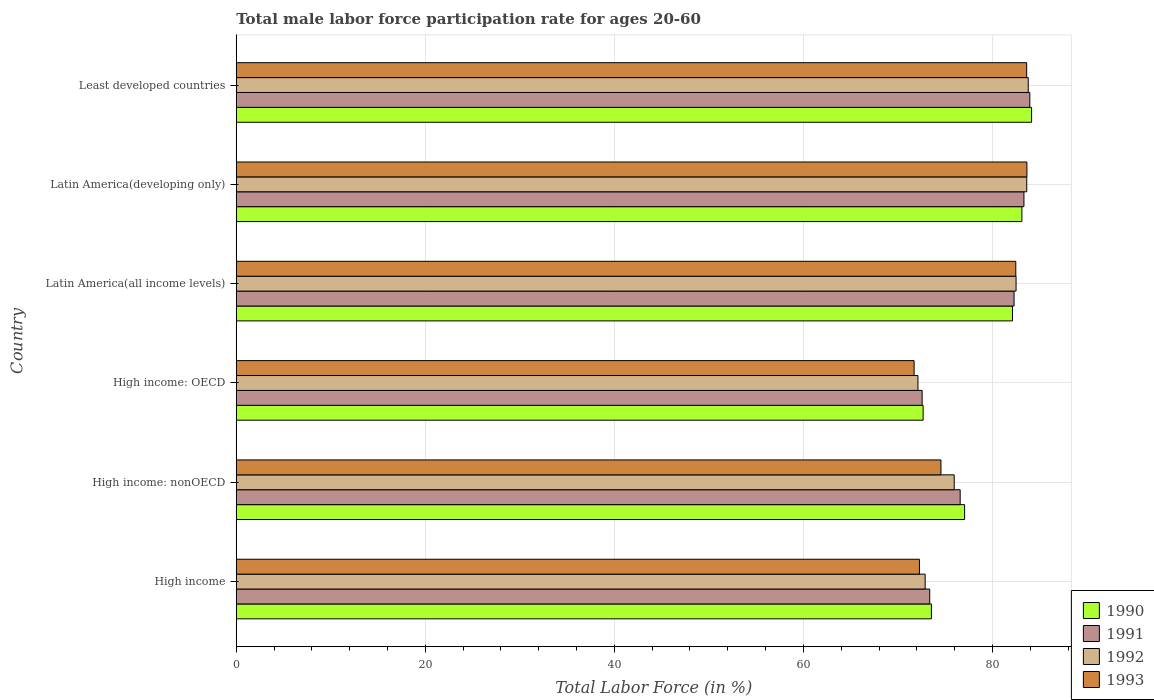Are the number of bars per tick equal to the number of legend labels?
Offer a very short reply. Yes. How many bars are there on the 2nd tick from the top?
Make the answer very short. 4. How many bars are there on the 3rd tick from the bottom?
Your response must be concise. 4. What is the label of the 1st group of bars from the top?
Your answer should be very brief. Least developed countries. What is the male labor force participation rate in 1991 in High income: nonOECD?
Give a very brief answer. 76.58. Across all countries, what is the maximum male labor force participation rate in 1991?
Your answer should be compact. 83.95. Across all countries, what is the minimum male labor force participation rate in 1992?
Your answer should be compact. 72.12. In which country was the male labor force participation rate in 1992 maximum?
Offer a very short reply. Least developed countries. In which country was the male labor force participation rate in 1990 minimum?
Your answer should be very brief. High income: OECD. What is the total male labor force participation rate in 1993 in the graph?
Ensure brevity in your answer.  468.27. What is the difference between the male labor force participation rate in 1993 in High income and that in Latin America(all income levels)?
Provide a short and direct response. -10.19. What is the difference between the male labor force participation rate in 1991 in Least developed countries and the male labor force participation rate in 1993 in High income: nonOECD?
Make the answer very short. 9.4. What is the average male labor force participation rate in 1990 per country?
Provide a succinct answer. 78.77. What is the difference between the male labor force participation rate in 1993 and male labor force participation rate in 1991 in High income: OECD?
Offer a terse response. -0.85. In how many countries, is the male labor force participation rate in 1993 greater than 20 %?
Offer a terse response. 6. What is the ratio of the male labor force participation rate in 1991 in High income to that in High income: OECD?
Offer a very short reply. 1.01. Is the male labor force participation rate in 1993 in High income: OECD less than that in Latin America(developing only)?
Offer a terse response. Yes. What is the difference between the highest and the second highest male labor force participation rate in 1990?
Offer a very short reply. 1.03. What is the difference between the highest and the lowest male labor force participation rate in 1993?
Offer a terse response. 11.93. Is the sum of the male labor force participation rate in 1992 in High income and Least developed countries greater than the maximum male labor force participation rate in 1990 across all countries?
Your response must be concise. Yes. What does the 4th bar from the top in High income represents?
Your answer should be compact. 1990. What does the 2nd bar from the bottom in High income: OECD represents?
Give a very brief answer. 1991. Is it the case that in every country, the sum of the male labor force participation rate in 1991 and male labor force participation rate in 1993 is greater than the male labor force participation rate in 1990?
Provide a succinct answer. Yes. How many bars are there?
Offer a terse response. 24. Are all the bars in the graph horizontal?
Offer a very short reply. Yes. Does the graph contain any zero values?
Ensure brevity in your answer.  No. How many legend labels are there?
Provide a succinct answer. 4. How are the legend labels stacked?
Offer a terse response. Vertical. What is the title of the graph?
Keep it short and to the point. Total male labor force participation rate for ages 20-60. Does "1988" appear as one of the legend labels in the graph?
Offer a very short reply. No. What is the label or title of the X-axis?
Keep it short and to the point. Total Labor Force (in %). What is the Total Labor Force (in %) in 1990 in High income?
Offer a very short reply. 73.54. What is the Total Labor Force (in %) of 1991 in High income?
Your response must be concise. 73.36. What is the Total Labor Force (in %) of 1992 in High income?
Make the answer very short. 72.88. What is the Total Labor Force (in %) in 1993 in High income?
Your answer should be compact. 72.28. What is the Total Labor Force (in %) in 1990 in High income: nonOECD?
Give a very brief answer. 77.05. What is the Total Labor Force (in %) of 1991 in High income: nonOECD?
Make the answer very short. 76.58. What is the Total Labor Force (in %) of 1992 in High income: nonOECD?
Your answer should be compact. 75.95. What is the Total Labor Force (in %) in 1993 in High income: nonOECD?
Your answer should be very brief. 74.55. What is the Total Labor Force (in %) of 1990 in High income: OECD?
Offer a terse response. 72.67. What is the Total Labor Force (in %) of 1991 in High income: OECD?
Make the answer very short. 72.56. What is the Total Labor Force (in %) in 1992 in High income: OECD?
Offer a terse response. 72.12. What is the Total Labor Force (in %) of 1993 in High income: OECD?
Provide a short and direct response. 71.71. What is the Total Labor Force (in %) of 1990 in Latin America(all income levels)?
Make the answer very short. 82.12. What is the Total Labor Force (in %) in 1991 in Latin America(all income levels)?
Offer a terse response. 82.29. What is the Total Labor Force (in %) of 1992 in Latin America(all income levels)?
Give a very brief answer. 82.5. What is the Total Labor Force (in %) of 1993 in Latin America(all income levels)?
Your answer should be very brief. 82.47. What is the Total Labor Force (in %) of 1990 in Latin America(developing only)?
Your response must be concise. 83.11. What is the Total Labor Force (in %) in 1991 in Latin America(developing only)?
Provide a short and direct response. 83.33. What is the Total Labor Force (in %) in 1992 in Latin America(developing only)?
Provide a succinct answer. 83.63. What is the Total Labor Force (in %) in 1993 in Latin America(developing only)?
Offer a very short reply. 83.64. What is the Total Labor Force (in %) of 1990 in Least developed countries?
Provide a short and direct response. 84.14. What is the Total Labor Force (in %) in 1991 in Least developed countries?
Offer a very short reply. 83.95. What is the Total Labor Force (in %) in 1992 in Least developed countries?
Your answer should be very brief. 83.78. What is the Total Labor Force (in %) of 1993 in Least developed countries?
Provide a succinct answer. 83.62. Across all countries, what is the maximum Total Labor Force (in %) of 1990?
Your response must be concise. 84.14. Across all countries, what is the maximum Total Labor Force (in %) of 1991?
Ensure brevity in your answer.  83.95. Across all countries, what is the maximum Total Labor Force (in %) in 1992?
Make the answer very short. 83.78. Across all countries, what is the maximum Total Labor Force (in %) of 1993?
Your answer should be compact. 83.64. Across all countries, what is the minimum Total Labor Force (in %) of 1990?
Keep it short and to the point. 72.67. Across all countries, what is the minimum Total Labor Force (in %) in 1991?
Offer a terse response. 72.56. Across all countries, what is the minimum Total Labor Force (in %) of 1992?
Offer a very short reply. 72.12. Across all countries, what is the minimum Total Labor Force (in %) of 1993?
Keep it short and to the point. 71.71. What is the total Total Labor Force (in %) of 1990 in the graph?
Provide a short and direct response. 472.63. What is the total Total Labor Force (in %) of 1991 in the graph?
Make the answer very short. 472.07. What is the total Total Labor Force (in %) of 1992 in the graph?
Keep it short and to the point. 470.86. What is the total Total Labor Force (in %) in 1993 in the graph?
Provide a short and direct response. 468.27. What is the difference between the Total Labor Force (in %) of 1990 in High income and that in High income: nonOECD?
Ensure brevity in your answer.  -3.51. What is the difference between the Total Labor Force (in %) of 1991 in High income and that in High income: nonOECD?
Provide a succinct answer. -3.22. What is the difference between the Total Labor Force (in %) of 1992 in High income and that in High income: nonOECD?
Provide a succinct answer. -3.07. What is the difference between the Total Labor Force (in %) of 1993 in High income and that in High income: nonOECD?
Offer a very short reply. -2.27. What is the difference between the Total Labor Force (in %) of 1990 in High income and that in High income: OECD?
Provide a succinct answer. 0.88. What is the difference between the Total Labor Force (in %) in 1991 in High income and that in High income: OECD?
Make the answer very short. 0.8. What is the difference between the Total Labor Force (in %) in 1992 in High income and that in High income: OECD?
Give a very brief answer. 0.76. What is the difference between the Total Labor Force (in %) in 1993 in High income and that in High income: OECD?
Make the answer very short. 0.56. What is the difference between the Total Labor Force (in %) of 1990 in High income and that in Latin America(all income levels)?
Your answer should be very brief. -8.58. What is the difference between the Total Labor Force (in %) in 1991 in High income and that in Latin America(all income levels)?
Your answer should be very brief. -8.92. What is the difference between the Total Labor Force (in %) in 1992 in High income and that in Latin America(all income levels)?
Provide a succinct answer. -9.62. What is the difference between the Total Labor Force (in %) in 1993 in High income and that in Latin America(all income levels)?
Your answer should be compact. -10.19. What is the difference between the Total Labor Force (in %) of 1990 in High income and that in Latin America(developing only)?
Provide a succinct answer. -9.57. What is the difference between the Total Labor Force (in %) of 1991 in High income and that in Latin America(developing only)?
Offer a very short reply. -9.97. What is the difference between the Total Labor Force (in %) in 1992 in High income and that in Latin America(developing only)?
Provide a short and direct response. -10.75. What is the difference between the Total Labor Force (in %) in 1993 in High income and that in Latin America(developing only)?
Give a very brief answer. -11.37. What is the difference between the Total Labor Force (in %) of 1990 in High income and that in Least developed countries?
Your answer should be compact. -10.6. What is the difference between the Total Labor Force (in %) in 1991 in High income and that in Least developed countries?
Keep it short and to the point. -10.59. What is the difference between the Total Labor Force (in %) of 1992 in High income and that in Least developed countries?
Offer a very short reply. -10.9. What is the difference between the Total Labor Force (in %) of 1993 in High income and that in Least developed countries?
Make the answer very short. -11.34. What is the difference between the Total Labor Force (in %) of 1990 in High income: nonOECD and that in High income: OECD?
Provide a short and direct response. 4.39. What is the difference between the Total Labor Force (in %) in 1991 in High income: nonOECD and that in High income: OECD?
Your answer should be very brief. 4.02. What is the difference between the Total Labor Force (in %) in 1992 in High income: nonOECD and that in High income: OECD?
Keep it short and to the point. 3.83. What is the difference between the Total Labor Force (in %) in 1993 in High income: nonOECD and that in High income: OECD?
Offer a terse response. 2.84. What is the difference between the Total Labor Force (in %) of 1990 in High income: nonOECD and that in Latin America(all income levels)?
Offer a terse response. -5.07. What is the difference between the Total Labor Force (in %) in 1991 in High income: nonOECD and that in Latin America(all income levels)?
Provide a short and direct response. -5.7. What is the difference between the Total Labor Force (in %) of 1992 in High income: nonOECD and that in Latin America(all income levels)?
Your response must be concise. -6.54. What is the difference between the Total Labor Force (in %) of 1993 in High income: nonOECD and that in Latin America(all income levels)?
Your answer should be compact. -7.92. What is the difference between the Total Labor Force (in %) in 1990 in High income: nonOECD and that in Latin America(developing only)?
Give a very brief answer. -6.06. What is the difference between the Total Labor Force (in %) of 1991 in High income: nonOECD and that in Latin America(developing only)?
Offer a very short reply. -6.74. What is the difference between the Total Labor Force (in %) of 1992 in High income: nonOECD and that in Latin America(developing only)?
Ensure brevity in your answer.  -7.68. What is the difference between the Total Labor Force (in %) in 1993 in High income: nonOECD and that in Latin America(developing only)?
Ensure brevity in your answer.  -9.09. What is the difference between the Total Labor Force (in %) in 1990 in High income: nonOECD and that in Least developed countries?
Keep it short and to the point. -7.09. What is the difference between the Total Labor Force (in %) in 1991 in High income: nonOECD and that in Least developed countries?
Give a very brief answer. -7.37. What is the difference between the Total Labor Force (in %) of 1992 in High income: nonOECD and that in Least developed countries?
Give a very brief answer. -7.83. What is the difference between the Total Labor Force (in %) in 1993 in High income: nonOECD and that in Least developed countries?
Ensure brevity in your answer.  -9.07. What is the difference between the Total Labor Force (in %) in 1990 in High income: OECD and that in Latin America(all income levels)?
Make the answer very short. -9.45. What is the difference between the Total Labor Force (in %) in 1991 in High income: OECD and that in Latin America(all income levels)?
Provide a short and direct response. -9.73. What is the difference between the Total Labor Force (in %) in 1992 in High income: OECD and that in Latin America(all income levels)?
Ensure brevity in your answer.  -10.38. What is the difference between the Total Labor Force (in %) of 1993 in High income: OECD and that in Latin America(all income levels)?
Keep it short and to the point. -10.76. What is the difference between the Total Labor Force (in %) of 1990 in High income: OECD and that in Latin America(developing only)?
Give a very brief answer. -10.45. What is the difference between the Total Labor Force (in %) of 1991 in High income: OECD and that in Latin America(developing only)?
Provide a short and direct response. -10.77. What is the difference between the Total Labor Force (in %) in 1992 in High income: OECD and that in Latin America(developing only)?
Your answer should be compact. -11.51. What is the difference between the Total Labor Force (in %) of 1993 in High income: OECD and that in Latin America(developing only)?
Your response must be concise. -11.93. What is the difference between the Total Labor Force (in %) of 1990 in High income: OECD and that in Least developed countries?
Your response must be concise. -11.47. What is the difference between the Total Labor Force (in %) of 1991 in High income: OECD and that in Least developed countries?
Your answer should be compact. -11.39. What is the difference between the Total Labor Force (in %) in 1992 in High income: OECD and that in Least developed countries?
Keep it short and to the point. -11.66. What is the difference between the Total Labor Force (in %) in 1993 in High income: OECD and that in Least developed countries?
Make the answer very short. -11.91. What is the difference between the Total Labor Force (in %) of 1990 in Latin America(all income levels) and that in Latin America(developing only)?
Keep it short and to the point. -1. What is the difference between the Total Labor Force (in %) of 1991 in Latin America(all income levels) and that in Latin America(developing only)?
Your answer should be compact. -1.04. What is the difference between the Total Labor Force (in %) of 1992 in Latin America(all income levels) and that in Latin America(developing only)?
Your response must be concise. -1.13. What is the difference between the Total Labor Force (in %) of 1993 in Latin America(all income levels) and that in Latin America(developing only)?
Your answer should be compact. -1.18. What is the difference between the Total Labor Force (in %) of 1990 in Latin America(all income levels) and that in Least developed countries?
Ensure brevity in your answer.  -2.02. What is the difference between the Total Labor Force (in %) in 1991 in Latin America(all income levels) and that in Least developed countries?
Offer a very short reply. -1.67. What is the difference between the Total Labor Force (in %) in 1992 in Latin America(all income levels) and that in Least developed countries?
Provide a short and direct response. -1.29. What is the difference between the Total Labor Force (in %) in 1993 in Latin America(all income levels) and that in Least developed countries?
Provide a short and direct response. -1.15. What is the difference between the Total Labor Force (in %) of 1990 in Latin America(developing only) and that in Least developed countries?
Offer a very short reply. -1.03. What is the difference between the Total Labor Force (in %) in 1991 in Latin America(developing only) and that in Least developed countries?
Your answer should be compact. -0.62. What is the difference between the Total Labor Force (in %) in 1992 in Latin America(developing only) and that in Least developed countries?
Your response must be concise. -0.16. What is the difference between the Total Labor Force (in %) in 1993 in Latin America(developing only) and that in Least developed countries?
Ensure brevity in your answer.  0.03. What is the difference between the Total Labor Force (in %) in 1990 in High income and the Total Labor Force (in %) in 1991 in High income: nonOECD?
Make the answer very short. -3.04. What is the difference between the Total Labor Force (in %) of 1990 in High income and the Total Labor Force (in %) of 1992 in High income: nonOECD?
Provide a succinct answer. -2.41. What is the difference between the Total Labor Force (in %) of 1990 in High income and the Total Labor Force (in %) of 1993 in High income: nonOECD?
Offer a terse response. -1.01. What is the difference between the Total Labor Force (in %) of 1991 in High income and the Total Labor Force (in %) of 1992 in High income: nonOECD?
Provide a succinct answer. -2.59. What is the difference between the Total Labor Force (in %) in 1991 in High income and the Total Labor Force (in %) in 1993 in High income: nonOECD?
Offer a very short reply. -1.19. What is the difference between the Total Labor Force (in %) in 1992 in High income and the Total Labor Force (in %) in 1993 in High income: nonOECD?
Ensure brevity in your answer.  -1.67. What is the difference between the Total Labor Force (in %) of 1990 in High income and the Total Labor Force (in %) of 1991 in High income: OECD?
Ensure brevity in your answer.  0.98. What is the difference between the Total Labor Force (in %) of 1990 in High income and the Total Labor Force (in %) of 1992 in High income: OECD?
Provide a short and direct response. 1.42. What is the difference between the Total Labor Force (in %) of 1990 in High income and the Total Labor Force (in %) of 1993 in High income: OECD?
Your response must be concise. 1.83. What is the difference between the Total Labor Force (in %) of 1991 in High income and the Total Labor Force (in %) of 1992 in High income: OECD?
Provide a succinct answer. 1.24. What is the difference between the Total Labor Force (in %) in 1991 in High income and the Total Labor Force (in %) in 1993 in High income: OECD?
Your response must be concise. 1.65. What is the difference between the Total Labor Force (in %) of 1992 in High income and the Total Labor Force (in %) of 1993 in High income: OECD?
Offer a very short reply. 1.17. What is the difference between the Total Labor Force (in %) in 1990 in High income and the Total Labor Force (in %) in 1991 in Latin America(all income levels)?
Ensure brevity in your answer.  -8.75. What is the difference between the Total Labor Force (in %) in 1990 in High income and the Total Labor Force (in %) in 1992 in Latin America(all income levels)?
Your answer should be compact. -8.96. What is the difference between the Total Labor Force (in %) in 1990 in High income and the Total Labor Force (in %) in 1993 in Latin America(all income levels)?
Your answer should be very brief. -8.93. What is the difference between the Total Labor Force (in %) of 1991 in High income and the Total Labor Force (in %) of 1992 in Latin America(all income levels)?
Make the answer very short. -9.13. What is the difference between the Total Labor Force (in %) in 1991 in High income and the Total Labor Force (in %) in 1993 in Latin America(all income levels)?
Offer a very short reply. -9.11. What is the difference between the Total Labor Force (in %) in 1992 in High income and the Total Labor Force (in %) in 1993 in Latin America(all income levels)?
Give a very brief answer. -9.59. What is the difference between the Total Labor Force (in %) of 1990 in High income and the Total Labor Force (in %) of 1991 in Latin America(developing only)?
Your response must be concise. -9.79. What is the difference between the Total Labor Force (in %) in 1990 in High income and the Total Labor Force (in %) in 1992 in Latin America(developing only)?
Offer a terse response. -10.09. What is the difference between the Total Labor Force (in %) in 1990 in High income and the Total Labor Force (in %) in 1993 in Latin America(developing only)?
Offer a terse response. -10.1. What is the difference between the Total Labor Force (in %) in 1991 in High income and the Total Labor Force (in %) in 1992 in Latin America(developing only)?
Provide a succinct answer. -10.27. What is the difference between the Total Labor Force (in %) in 1991 in High income and the Total Labor Force (in %) in 1993 in Latin America(developing only)?
Make the answer very short. -10.28. What is the difference between the Total Labor Force (in %) in 1992 in High income and the Total Labor Force (in %) in 1993 in Latin America(developing only)?
Keep it short and to the point. -10.76. What is the difference between the Total Labor Force (in %) of 1990 in High income and the Total Labor Force (in %) of 1991 in Least developed countries?
Your answer should be compact. -10.41. What is the difference between the Total Labor Force (in %) of 1990 in High income and the Total Labor Force (in %) of 1992 in Least developed countries?
Make the answer very short. -10.24. What is the difference between the Total Labor Force (in %) in 1990 in High income and the Total Labor Force (in %) in 1993 in Least developed countries?
Provide a succinct answer. -10.08. What is the difference between the Total Labor Force (in %) of 1991 in High income and the Total Labor Force (in %) of 1992 in Least developed countries?
Ensure brevity in your answer.  -10.42. What is the difference between the Total Labor Force (in %) in 1991 in High income and the Total Labor Force (in %) in 1993 in Least developed countries?
Give a very brief answer. -10.26. What is the difference between the Total Labor Force (in %) of 1992 in High income and the Total Labor Force (in %) of 1993 in Least developed countries?
Give a very brief answer. -10.74. What is the difference between the Total Labor Force (in %) in 1990 in High income: nonOECD and the Total Labor Force (in %) in 1991 in High income: OECD?
Offer a terse response. 4.49. What is the difference between the Total Labor Force (in %) in 1990 in High income: nonOECD and the Total Labor Force (in %) in 1992 in High income: OECD?
Your answer should be compact. 4.93. What is the difference between the Total Labor Force (in %) in 1990 in High income: nonOECD and the Total Labor Force (in %) in 1993 in High income: OECD?
Offer a terse response. 5.34. What is the difference between the Total Labor Force (in %) of 1991 in High income: nonOECD and the Total Labor Force (in %) of 1992 in High income: OECD?
Your answer should be compact. 4.46. What is the difference between the Total Labor Force (in %) of 1991 in High income: nonOECD and the Total Labor Force (in %) of 1993 in High income: OECD?
Provide a succinct answer. 4.87. What is the difference between the Total Labor Force (in %) in 1992 in High income: nonOECD and the Total Labor Force (in %) in 1993 in High income: OECD?
Provide a short and direct response. 4.24. What is the difference between the Total Labor Force (in %) of 1990 in High income: nonOECD and the Total Labor Force (in %) of 1991 in Latin America(all income levels)?
Make the answer very short. -5.23. What is the difference between the Total Labor Force (in %) in 1990 in High income: nonOECD and the Total Labor Force (in %) in 1992 in Latin America(all income levels)?
Offer a very short reply. -5.45. What is the difference between the Total Labor Force (in %) of 1990 in High income: nonOECD and the Total Labor Force (in %) of 1993 in Latin America(all income levels)?
Offer a very short reply. -5.42. What is the difference between the Total Labor Force (in %) in 1991 in High income: nonOECD and the Total Labor Force (in %) in 1992 in Latin America(all income levels)?
Provide a short and direct response. -5.91. What is the difference between the Total Labor Force (in %) in 1991 in High income: nonOECD and the Total Labor Force (in %) in 1993 in Latin America(all income levels)?
Offer a terse response. -5.88. What is the difference between the Total Labor Force (in %) in 1992 in High income: nonOECD and the Total Labor Force (in %) in 1993 in Latin America(all income levels)?
Keep it short and to the point. -6.52. What is the difference between the Total Labor Force (in %) of 1990 in High income: nonOECD and the Total Labor Force (in %) of 1991 in Latin America(developing only)?
Provide a succinct answer. -6.28. What is the difference between the Total Labor Force (in %) in 1990 in High income: nonOECD and the Total Labor Force (in %) in 1992 in Latin America(developing only)?
Give a very brief answer. -6.58. What is the difference between the Total Labor Force (in %) of 1990 in High income: nonOECD and the Total Labor Force (in %) of 1993 in Latin America(developing only)?
Offer a very short reply. -6.59. What is the difference between the Total Labor Force (in %) in 1991 in High income: nonOECD and the Total Labor Force (in %) in 1992 in Latin America(developing only)?
Give a very brief answer. -7.04. What is the difference between the Total Labor Force (in %) in 1991 in High income: nonOECD and the Total Labor Force (in %) in 1993 in Latin America(developing only)?
Offer a terse response. -7.06. What is the difference between the Total Labor Force (in %) in 1992 in High income: nonOECD and the Total Labor Force (in %) in 1993 in Latin America(developing only)?
Your response must be concise. -7.69. What is the difference between the Total Labor Force (in %) of 1990 in High income: nonOECD and the Total Labor Force (in %) of 1991 in Least developed countries?
Your answer should be very brief. -6.9. What is the difference between the Total Labor Force (in %) of 1990 in High income: nonOECD and the Total Labor Force (in %) of 1992 in Least developed countries?
Your answer should be very brief. -6.73. What is the difference between the Total Labor Force (in %) of 1990 in High income: nonOECD and the Total Labor Force (in %) of 1993 in Least developed countries?
Make the answer very short. -6.57. What is the difference between the Total Labor Force (in %) of 1991 in High income: nonOECD and the Total Labor Force (in %) of 1992 in Least developed countries?
Make the answer very short. -7.2. What is the difference between the Total Labor Force (in %) of 1991 in High income: nonOECD and the Total Labor Force (in %) of 1993 in Least developed countries?
Keep it short and to the point. -7.03. What is the difference between the Total Labor Force (in %) in 1992 in High income: nonOECD and the Total Labor Force (in %) in 1993 in Least developed countries?
Your response must be concise. -7.67. What is the difference between the Total Labor Force (in %) of 1990 in High income: OECD and the Total Labor Force (in %) of 1991 in Latin America(all income levels)?
Ensure brevity in your answer.  -9.62. What is the difference between the Total Labor Force (in %) in 1990 in High income: OECD and the Total Labor Force (in %) in 1992 in Latin America(all income levels)?
Provide a short and direct response. -9.83. What is the difference between the Total Labor Force (in %) in 1990 in High income: OECD and the Total Labor Force (in %) in 1993 in Latin America(all income levels)?
Ensure brevity in your answer.  -9.8. What is the difference between the Total Labor Force (in %) in 1991 in High income: OECD and the Total Labor Force (in %) in 1992 in Latin America(all income levels)?
Offer a terse response. -9.94. What is the difference between the Total Labor Force (in %) of 1991 in High income: OECD and the Total Labor Force (in %) of 1993 in Latin America(all income levels)?
Offer a terse response. -9.91. What is the difference between the Total Labor Force (in %) of 1992 in High income: OECD and the Total Labor Force (in %) of 1993 in Latin America(all income levels)?
Your response must be concise. -10.35. What is the difference between the Total Labor Force (in %) of 1990 in High income: OECD and the Total Labor Force (in %) of 1991 in Latin America(developing only)?
Give a very brief answer. -10.66. What is the difference between the Total Labor Force (in %) in 1990 in High income: OECD and the Total Labor Force (in %) in 1992 in Latin America(developing only)?
Offer a very short reply. -10.96. What is the difference between the Total Labor Force (in %) in 1990 in High income: OECD and the Total Labor Force (in %) in 1993 in Latin America(developing only)?
Your response must be concise. -10.98. What is the difference between the Total Labor Force (in %) of 1991 in High income: OECD and the Total Labor Force (in %) of 1992 in Latin America(developing only)?
Provide a short and direct response. -11.07. What is the difference between the Total Labor Force (in %) of 1991 in High income: OECD and the Total Labor Force (in %) of 1993 in Latin America(developing only)?
Give a very brief answer. -11.09. What is the difference between the Total Labor Force (in %) of 1992 in High income: OECD and the Total Labor Force (in %) of 1993 in Latin America(developing only)?
Keep it short and to the point. -11.52. What is the difference between the Total Labor Force (in %) in 1990 in High income: OECD and the Total Labor Force (in %) in 1991 in Least developed countries?
Provide a short and direct response. -11.29. What is the difference between the Total Labor Force (in %) in 1990 in High income: OECD and the Total Labor Force (in %) in 1992 in Least developed countries?
Keep it short and to the point. -11.12. What is the difference between the Total Labor Force (in %) in 1990 in High income: OECD and the Total Labor Force (in %) in 1993 in Least developed countries?
Provide a short and direct response. -10.95. What is the difference between the Total Labor Force (in %) in 1991 in High income: OECD and the Total Labor Force (in %) in 1992 in Least developed countries?
Provide a short and direct response. -11.23. What is the difference between the Total Labor Force (in %) of 1991 in High income: OECD and the Total Labor Force (in %) of 1993 in Least developed countries?
Provide a short and direct response. -11.06. What is the difference between the Total Labor Force (in %) in 1992 in High income: OECD and the Total Labor Force (in %) in 1993 in Least developed countries?
Your answer should be very brief. -11.5. What is the difference between the Total Labor Force (in %) of 1990 in Latin America(all income levels) and the Total Labor Force (in %) of 1991 in Latin America(developing only)?
Provide a succinct answer. -1.21. What is the difference between the Total Labor Force (in %) in 1990 in Latin America(all income levels) and the Total Labor Force (in %) in 1992 in Latin America(developing only)?
Ensure brevity in your answer.  -1.51. What is the difference between the Total Labor Force (in %) of 1990 in Latin America(all income levels) and the Total Labor Force (in %) of 1993 in Latin America(developing only)?
Provide a succinct answer. -1.53. What is the difference between the Total Labor Force (in %) of 1991 in Latin America(all income levels) and the Total Labor Force (in %) of 1992 in Latin America(developing only)?
Your response must be concise. -1.34. What is the difference between the Total Labor Force (in %) of 1991 in Latin America(all income levels) and the Total Labor Force (in %) of 1993 in Latin America(developing only)?
Your response must be concise. -1.36. What is the difference between the Total Labor Force (in %) in 1992 in Latin America(all income levels) and the Total Labor Force (in %) in 1993 in Latin America(developing only)?
Provide a short and direct response. -1.15. What is the difference between the Total Labor Force (in %) in 1990 in Latin America(all income levels) and the Total Labor Force (in %) in 1991 in Least developed countries?
Ensure brevity in your answer.  -1.83. What is the difference between the Total Labor Force (in %) in 1990 in Latin America(all income levels) and the Total Labor Force (in %) in 1992 in Least developed countries?
Offer a terse response. -1.67. What is the difference between the Total Labor Force (in %) of 1990 in Latin America(all income levels) and the Total Labor Force (in %) of 1993 in Least developed countries?
Your response must be concise. -1.5. What is the difference between the Total Labor Force (in %) of 1991 in Latin America(all income levels) and the Total Labor Force (in %) of 1992 in Least developed countries?
Provide a short and direct response. -1.5. What is the difference between the Total Labor Force (in %) in 1991 in Latin America(all income levels) and the Total Labor Force (in %) in 1993 in Least developed countries?
Make the answer very short. -1.33. What is the difference between the Total Labor Force (in %) of 1992 in Latin America(all income levels) and the Total Labor Force (in %) of 1993 in Least developed countries?
Your answer should be very brief. -1.12. What is the difference between the Total Labor Force (in %) in 1990 in Latin America(developing only) and the Total Labor Force (in %) in 1991 in Least developed countries?
Your answer should be compact. -0.84. What is the difference between the Total Labor Force (in %) in 1990 in Latin America(developing only) and the Total Labor Force (in %) in 1992 in Least developed countries?
Your answer should be compact. -0.67. What is the difference between the Total Labor Force (in %) of 1990 in Latin America(developing only) and the Total Labor Force (in %) of 1993 in Least developed countries?
Offer a very short reply. -0.5. What is the difference between the Total Labor Force (in %) in 1991 in Latin America(developing only) and the Total Labor Force (in %) in 1992 in Least developed countries?
Your answer should be compact. -0.46. What is the difference between the Total Labor Force (in %) of 1991 in Latin America(developing only) and the Total Labor Force (in %) of 1993 in Least developed countries?
Keep it short and to the point. -0.29. What is the difference between the Total Labor Force (in %) in 1992 in Latin America(developing only) and the Total Labor Force (in %) in 1993 in Least developed countries?
Your answer should be compact. 0.01. What is the average Total Labor Force (in %) of 1990 per country?
Give a very brief answer. 78.77. What is the average Total Labor Force (in %) in 1991 per country?
Offer a terse response. 78.68. What is the average Total Labor Force (in %) in 1992 per country?
Ensure brevity in your answer.  78.48. What is the average Total Labor Force (in %) in 1993 per country?
Ensure brevity in your answer.  78.04. What is the difference between the Total Labor Force (in %) of 1990 and Total Labor Force (in %) of 1991 in High income?
Your answer should be compact. 0.18. What is the difference between the Total Labor Force (in %) of 1990 and Total Labor Force (in %) of 1992 in High income?
Your answer should be compact. 0.66. What is the difference between the Total Labor Force (in %) in 1990 and Total Labor Force (in %) in 1993 in High income?
Provide a short and direct response. 1.27. What is the difference between the Total Labor Force (in %) in 1991 and Total Labor Force (in %) in 1992 in High income?
Provide a short and direct response. 0.48. What is the difference between the Total Labor Force (in %) of 1991 and Total Labor Force (in %) of 1993 in High income?
Offer a very short reply. 1.09. What is the difference between the Total Labor Force (in %) in 1992 and Total Labor Force (in %) in 1993 in High income?
Your answer should be compact. 0.6. What is the difference between the Total Labor Force (in %) of 1990 and Total Labor Force (in %) of 1991 in High income: nonOECD?
Your response must be concise. 0.47. What is the difference between the Total Labor Force (in %) of 1990 and Total Labor Force (in %) of 1992 in High income: nonOECD?
Offer a terse response. 1.1. What is the difference between the Total Labor Force (in %) in 1990 and Total Labor Force (in %) in 1993 in High income: nonOECD?
Give a very brief answer. 2.5. What is the difference between the Total Labor Force (in %) of 1991 and Total Labor Force (in %) of 1992 in High income: nonOECD?
Give a very brief answer. 0.63. What is the difference between the Total Labor Force (in %) of 1991 and Total Labor Force (in %) of 1993 in High income: nonOECD?
Provide a short and direct response. 2.03. What is the difference between the Total Labor Force (in %) of 1992 and Total Labor Force (in %) of 1993 in High income: nonOECD?
Your answer should be very brief. 1.4. What is the difference between the Total Labor Force (in %) in 1990 and Total Labor Force (in %) in 1991 in High income: OECD?
Offer a terse response. 0.11. What is the difference between the Total Labor Force (in %) of 1990 and Total Labor Force (in %) of 1992 in High income: OECD?
Your response must be concise. 0.55. What is the difference between the Total Labor Force (in %) in 1990 and Total Labor Force (in %) in 1993 in High income: OECD?
Keep it short and to the point. 0.95. What is the difference between the Total Labor Force (in %) of 1991 and Total Labor Force (in %) of 1992 in High income: OECD?
Offer a very short reply. 0.44. What is the difference between the Total Labor Force (in %) of 1991 and Total Labor Force (in %) of 1993 in High income: OECD?
Your answer should be compact. 0.85. What is the difference between the Total Labor Force (in %) in 1992 and Total Labor Force (in %) in 1993 in High income: OECD?
Make the answer very short. 0.41. What is the difference between the Total Labor Force (in %) in 1990 and Total Labor Force (in %) in 1991 in Latin America(all income levels)?
Your answer should be compact. -0.17. What is the difference between the Total Labor Force (in %) of 1990 and Total Labor Force (in %) of 1992 in Latin America(all income levels)?
Keep it short and to the point. -0.38. What is the difference between the Total Labor Force (in %) of 1990 and Total Labor Force (in %) of 1993 in Latin America(all income levels)?
Make the answer very short. -0.35. What is the difference between the Total Labor Force (in %) in 1991 and Total Labor Force (in %) in 1992 in Latin America(all income levels)?
Make the answer very short. -0.21. What is the difference between the Total Labor Force (in %) of 1991 and Total Labor Force (in %) of 1993 in Latin America(all income levels)?
Provide a succinct answer. -0.18. What is the difference between the Total Labor Force (in %) of 1992 and Total Labor Force (in %) of 1993 in Latin America(all income levels)?
Offer a terse response. 0.03. What is the difference between the Total Labor Force (in %) in 1990 and Total Labor Force (in %) in 1991 in Latin America(developing only)?
Give a very brief answer. -0.22. What is the difference between the Total Labor Force (in %) of 1990 and Total Labor Force (in %) of 1992 in Latin America(developing only)?
Your answer should be compact. -0.51. What is the difference between the Total Labor Force (in %) of 1990 and Total Labor Force (in %) of 1993 in Latin America(developing only)?
Make the answer very short. -0.53. What is the difference between the Total Labor Force (in %) in 1991 and Total Labor Force (in %) in 1992 in Latin America(developing only)?
Provide a succinct answer. -0.3. What is the difference between the Total Labor Force (in %) of 1991 and Total Labor Force (in %) of 1993 in Latin America(developing only)?
Provide a succinct answer. -0.32. What is the difference between the Total Labor Force (in %) of 1992 and Total Labor Force (in %) of 1993 in Latin America(developing only)?
Offer a very short reply. -0.02. What is the difference between the Total Labor Force (in %) of 1990 and Total Labor Force (in %) of 1991 in Least developed countries?
Your answer should be compact. 0.19. What is the difference between the Total Labor Force (in %) in 1990 and Total Labor Force (in %) in 1992 in Least developed countries?
Offer a terse response. 0.36. What is the difference between the Total Labor Force (in %) in 1990 and Total Labor Force (in %) in 1993 in Least developed countries?
Offer a terse response. 0.52. What is the difference between the Total Labor Force (in %) in 1991 and Total Labor Force (in %) in 1992 in Least developed countries?
Keep it short and to the point. 0.17. What is the difference between the Total Labor Force (in %) of 1991 and Total Labor Force (in %) of 1993 in Least developed countries?
Give a very brief answer. 0.33. What is the difference between the Total Labor Force (in %) of 1992 and Total Labor Force (in %) of 1993 in Least developed countries?
Offer a very short reply. 0.17. What is the ratio of the Total Labor Force (in %) of 1990 in High income to that in High income: nonOECD?
Ensure brevity in your answer.  0.95. What is the ratio of the Total Labor Force (in %) of 1991 in High income to that in High income: nonOECD?
Offer a terse response. 0.96. What is the ratio of the Total Labor Force (in %) of 1992 in High income to that in High income: nonOECD?
Give a very brief answer. 0.96. What is the ratio of the Total Labor Force (in %) in 1993 in High income to that in High income: nonOECD?
Your response must be concise. 0.97. What is the ratio of the Total Labor Force (in %) in 1991 in High income to that in High income: OECD?
Your answer should be compact. 1.01. What is the ratio of the Total Labor Force (in %) of 1992 in High income to that in High income: OECD?
Your answer should be very brief. 1.01. What is the ratio of the Total Labor Force (in %) in 1993 in High income to that in High income: OECD?
Keep it short and to the point. 1.01. What is the ratio of the Total Labor Force (in %) in 1990 in High income to that in Latin America(all income levels)?
Make the answer very short. 0.9. What is the ratio of the Total Labor Force (in %) in 1991 in High income to that in Latin America(all income levels)?
Offer a very short reply. 0.89. What is the ratio of the Total Labor Force (in %) of 1992 in High income to that in Latin America(all income levels)?
Make the answer very short. 0.88. What is the ratio of the Total Labor Force (in %) in 1993 in High income to that in Latin America(all income levels)?
Your answer should be very brief. 0.88. What is the ratio of the Total Labor Force (in %) of 1990 in High income to that in Latin America(developing only)?
Provide a succinct answer. 0.88. What is the ratio of the Total Labor Force (in %) in 1991 in High income to that in Latin America(developing only)?
Offer a terse response. 0.88. What is the ratio of the Total Labor Force (in %) in 1992 in High income to that in Latin America(developing only)?
Your answer should be very brief. 0.87. What is the ratio of the Total Labor Force (in %) in 1993 in High income to that in Latin America(developing only)?
Give a very brief answer. 0.86. What is the ratio of the Total Labor Force (in %) of 1990 in High income to that in Least developed countries?
Offer a very short reply. 0.87. What is the ratio of the Total Labor Force (in %) of 1991 in High income to that in Least developed countries?
Keep it short and to the point. 0.87. What is the ratio of the Total Labor Force (in %) of 1992 in High income to that in Least developed countries?
Make the answer very short. 0.87. What is the ratio of the Total Labor Force (in %) in 1993 in High income to that in Least developed countries?
Offer a very short reply. 0.86. What is the ratio of the Total Labor Force (in %) in 1990 in High income: nonOECD to that in High income: OECD?
Ensure brevity in your answer.  1.06. What is the ratio of the Total Labor Force (in %) of 1991 in High income: nonOECD to that in High income: OECD?
Provide a succinct answer. 1.06. What is the ratio of the Total Labor Force (in %) of 1992 in High income: nonOECD to that in High income: OECD?
Provide a succinct answer. 1.05. What is the ratio of the Total Labor Force (in %) in 1993 in High income: nonOECD to that in High income: OECD?
Your answer should be compact. 1.04. What is the ratio of the Total Labor Force (in %) of 1990 in High income: nonOECD to that in Latin America(all income levels)?
Keep it short and to the point. 0.94. What is the ratio of the Total Labor Force (in %) of 1991 in High income: nonOECD to that in Latin America(all income levels)?
Ensure brevity in your answer.  0.93. What is the ratio of the Total Labor Force (in %) in 1992 in High income: nonOECD to that in Latin America(all income levels)?
Ensure brevity in your answer.  0.92. What is the ratio of the Total Labor Force (in %) in 1993 in High income: nonOECD to that in Latin America(all income levels)?
Provide a succinct answer. 0.9. What is the ratio of the Total Labor Force (in %) of 1990 in High income: nonOECD to that in Latin America(developing only)?
Offer a terse response. 0.93. What is the ratio of the Total Labor Force (in %) in 1991 in High income: nonOECD to that in Latin America(developing only)?
Offer a terse response. 0.92. What is the ratio of the Total Labor Force (in %) of 1992 in High income: nonOECD to that in Latin America(developing only)?
Ensure brevity in your answer.  0.91. What is the ratio of the Total Labor Force (in %) of 1993 in High income: nonOECD to that in Latin America(developing only)?
Keep it short and to the point. 0.89. What is the ratio of the Total Labor Force (in %) in 1990 in High income: nonOECD to that in Least developed countries?
Keep it short and to the point. 0.92. What is the ratio of the Total Labor Force (in %) in 1991 in High income: nonOECD to that in Least developed countries?
Make the answer very short. 0.91. What is the ratio of the Total Labor Force (in %) in 1992 in High income: nonOECD to that in Least developed countries?
Your answer should be very brief. 0.91. What is the ratio of the Total Labor Force (in %) in 1993 in High income: nonOECD to that in Least developed countries?
Keep it short and to the point. 0.89. What is the ratio of the Total Labor Force (in %) of 1990 in High income: OECD to that in Latin America(all income levels)?
Your answer should be compact. 0.88. What is the ratio of the Total Labor Force (in %) of 1991 in High income: OECD to that in Latin America(all income levels)?
Provide a succinct answer. 0.88. What is the ratio of the Total Labor Force (in %) of 1992 in High income: OECD to that in Latin America(all income levels)?
Ensure brevity in your answer.  0.87. What is the ratio of the Total Labor Force (in %) in 1993 in High income: OECD to that in Latin America(all income levels)?
Your answer should be compact. 0.87. What is the ratio of the Total Labor Force (in %) in 1990 in High income: OECD to that in Latin America(developing only)?
Your answer should be compact. 0.87. What is the ratio of the Total Labor Force (in %) of 1991 in High income: OECD to that in Latin America(developing only)?
Keep it short and to the point. 0.87. What is the ratio of the Total Labor Force (in %) of 1992 in High income: OECD to that in Latin America(developing only)?
Keep it short and to the point. 0.86. What is the ratio of the Total Labor Force (in %) of 1993 in High income: OECD to that in Latin America(developing only)?
Offer a terse response. 0.86. What is the ratio of the Total Labor Force (in %) of 1990 in High income: OECD to that in Least developed countries?
Ensure brevity in your answer.  0.86. What is the ratio of the Total Labor Force (in %) in 1991 in High income: OECD to that in Least developed countries?
Offer a terse response. 0.86. What is the ratio of the Total Labor Force (in %) of 1992 in High income: OECD to that in Least developed countries?
Ensure brevity in your answer.  0.86. What is the ratio of the Total Labor Force (in %) in 1993 in High income: OECD to that in Least developed countries?
Offer a very short reply. 0.86. What is the ratio of the Total Labor Force (in %) in 1991 in Latin America(all income levels) to that in Latin America(developing only)?
Provide a succinct answer. 0.99. What is the ratio of the Total Labor Force (in %) in 1992 in Latin America(all income levels) to that in Latin America(developing only)?
Your answer should be compact. 0.99. What is the ratio of the Total Labor Force (in %) of 1993 in Latin America(all income levels) to that in Latin America(developing only)?
Your answer should be very brief. 0.99. What is the ratio of the Total Labor Force (in %) of 1991 in Latin America(all income levels) to that in Least developed countries?
Provide a short and direct response. 0.98. What is the ratio of the Total Labor Force (in %) of 1992 in Latin America(all income levels) to that in Least developed countries?
Provide a succinct answer. 0.98. What is the ratio of the Total Labor Force (in %) of 1993 in Latin America(all income levels) to that in Least developed countries?
Provide a short and direct response. 0.99. What is the ratio of the Total Labor Force (in %) in 1990 in Latin America(developing only) to that in Least developed countries?
Give a very brief answer. 0.99. What is the ratio of the Total Labor Force (in %) in 1992 in Latin America(developing only) to that in Least developed countries?
Your answer should be compact. 1. What is the difference between the highest and the second highest Total Labor Force (in %) in 1990?
Offer a very short reply. 1.03. What is the difference between the highest and the second highest Total Labor Force (in %) in 1991?
Provide a short and direct response. 0.62. What is the difference between the highest and the second highest Total Labor Force (in %) in 1992?
Give a very brief answer. 0.16. What is the difference between the highest and the second highest Total Labor Force (in %) of 1993?
Your answer should be compact. 0.03. What is the difference between the highest and the lowest Total Labor Force (in %) in 1990?
Offer a terse response. 11.47. What is the difference between the highest and the lowest Total Labor Force (in %) in 1991?
Your answer should be compact. 11.39. What is the difference between the highest and the lowest Total Labor Force (in %) of 1992?
Ensure brevity in your answer.  11.66. What is the difference between the highest and the lowest Total Labor Force (in %) in 1993?
Keep it short and to the point. 11.93. 